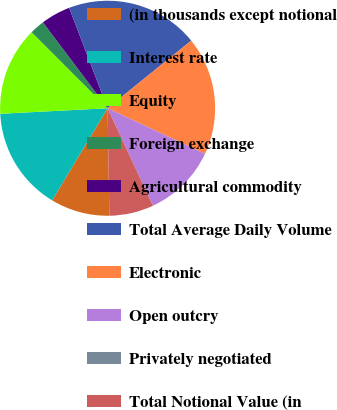Convert chart. <chart><loc_0><loc_0><loc_500><loc_500><pie_chart><fcel>(in thousands except notional<fcel>Interest rate<fcel>Equity<fcel>Foreign exchange<fcel>Agricultural commodity<fcel>Total Average Daily Volume<fcel>Electronic<fcel>Open outcry<fcel>Privately negotiated<fcel>Total Notional Value (in<nl><fcel>8.89%<fcel>15.55%<fcel>13.33%<fcel>2.22%<fcel>4.45%<fcel>20.0%<fcel>17.78%<fcel>11.11%<fcel>0.0%<fcel>6.67%<nl></chart> 